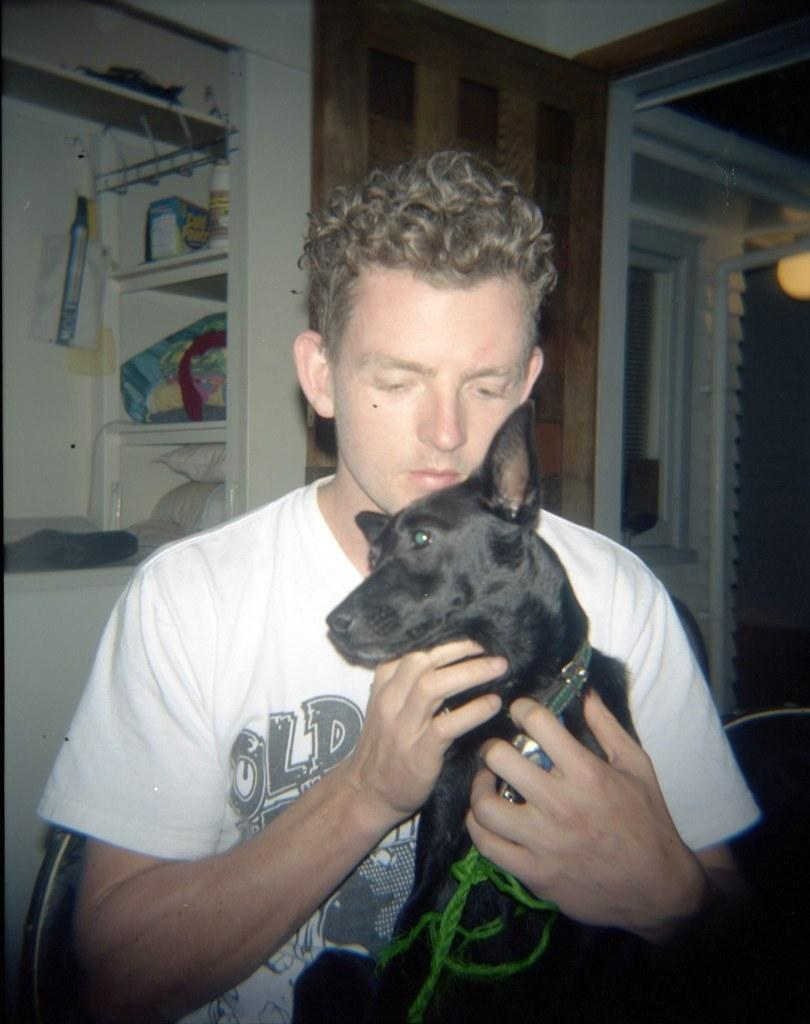Who is present in the image? There is a man in the image. What is the man holding in the image? The man is holding a black dog. What can be seen in the background of the image? There is a door visible in the background of the image. How many quarters are visible on the ground in the image? There are no quarters visible on the ground in the image. 